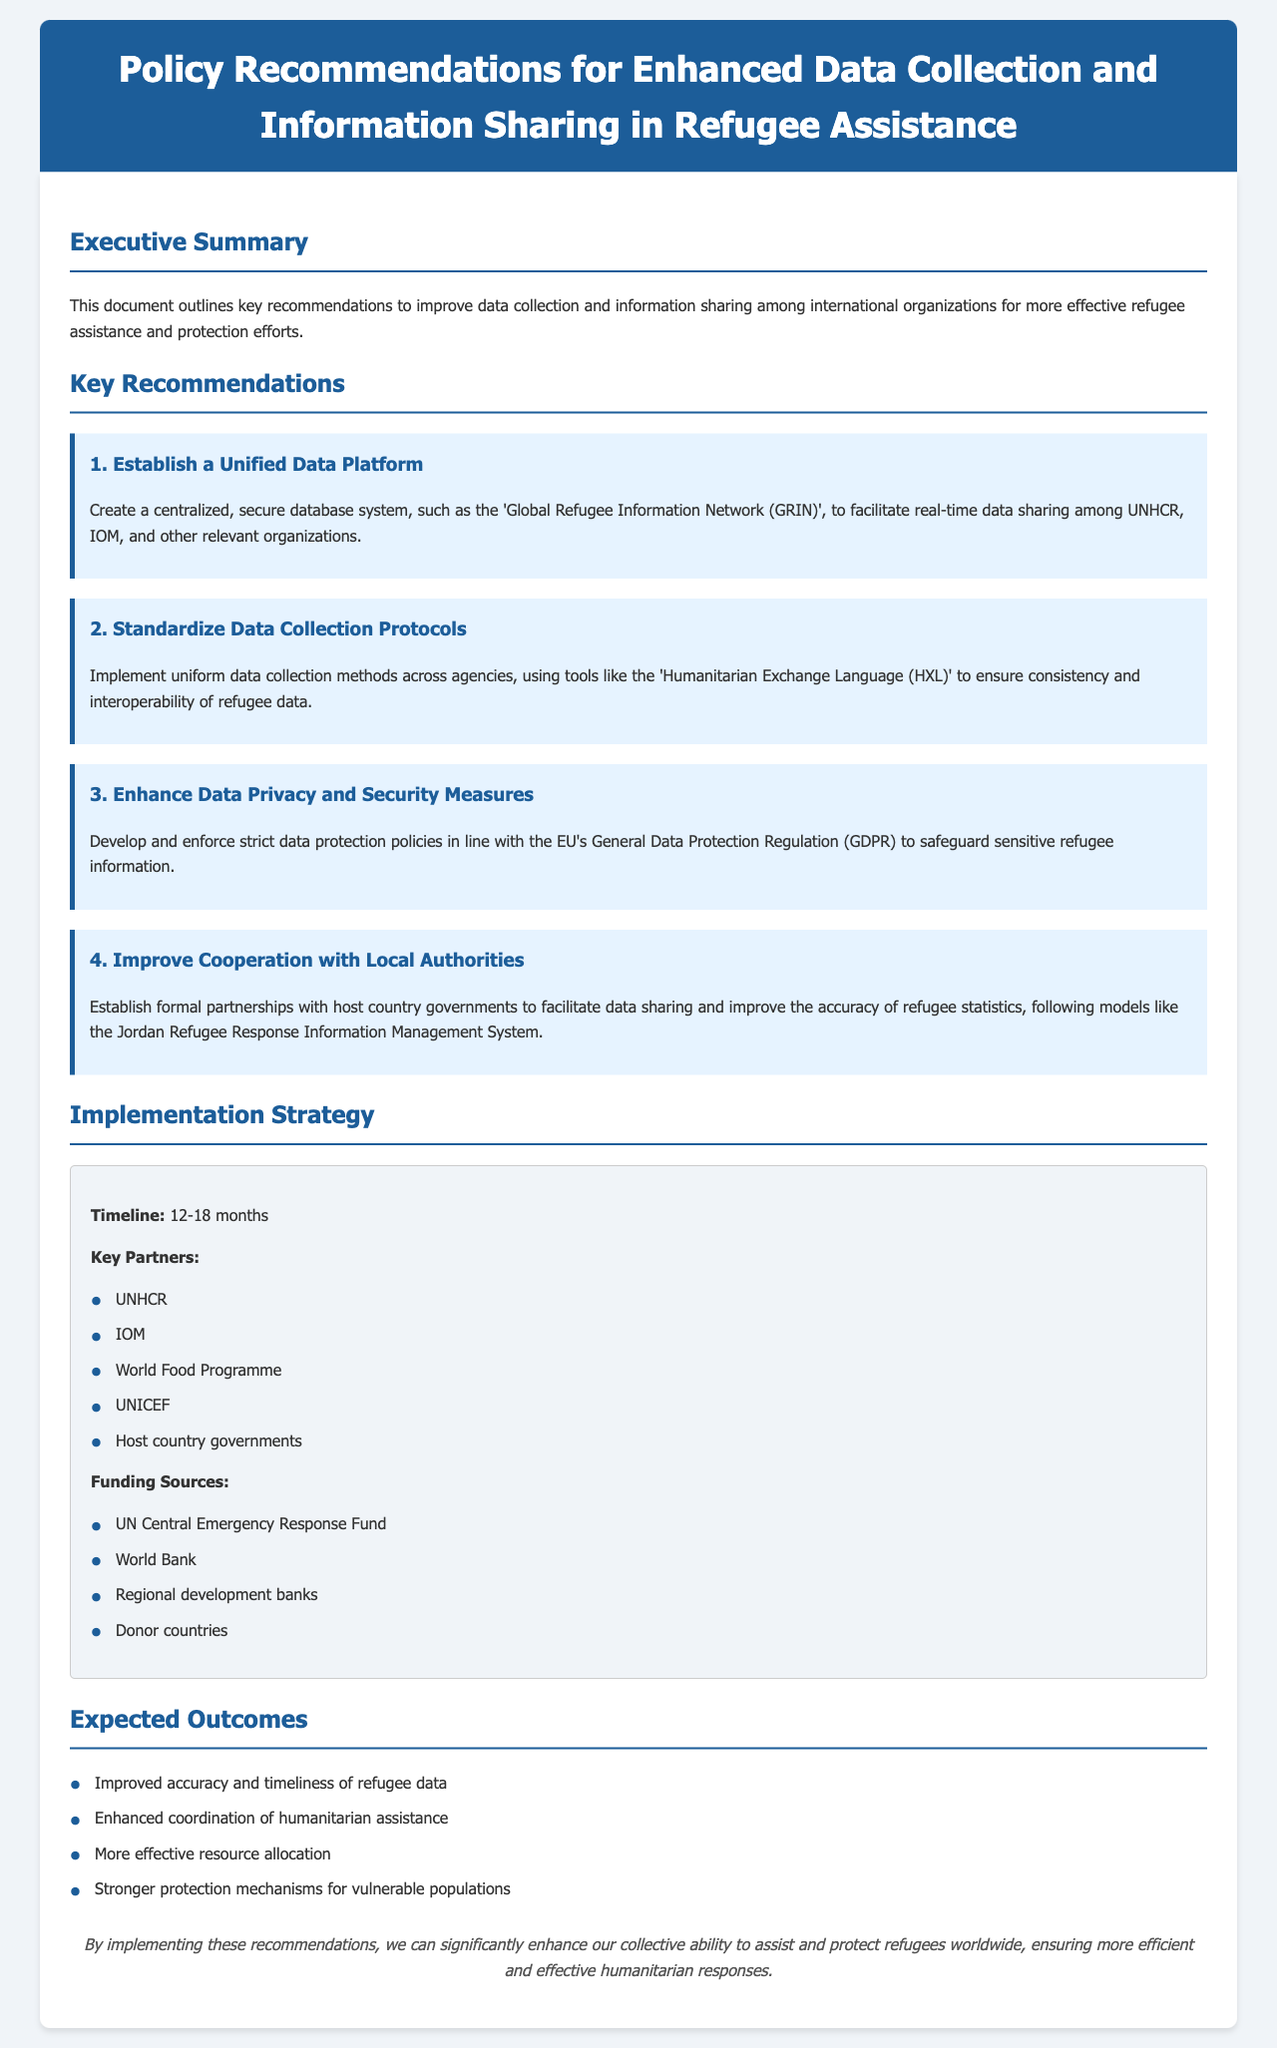What is the title of the document? The title is stated prominently at the top of the document.
Answer: Policy Recommendations for Enhanced Data Collection and Information Sharing in Refugee Assistance What is the name of the centralized database system proposed? The document introduces a specific name for the database in its recommendations section.
Answer: Global Refugee Information Network (GRIN) How many key recommendations are outlined in the document? The number of recommendations is noted in the section heading.
Answer: Four Which data protection regulation is mentioned for safeguarding refugee information? The document refers to a specific regulation related to data privacy.
Answer: GDPR What is the timeline proposed for the implementation of the recommendations? The timeline is clearly stated in the implementation strategy section.
Answer: 12-18 months Which organization is suggested as a key partner in the implementation strategy? The document lists multiple organizations in the partnership section.
Answer: UNHCR What is one expected outcome of enhancing data collection? The expected outcomes include several benefits of improved data collection mentioned in the document.
Answer: Improved accuracy and timeliness of refugee data What tool is recommended for standardizing data collection? The document specifies a tool intended to ensure consistency in data collection methods.
Answer: Humanitarian Exchange Language (HXL) Which funding source is listed for the proposed implementations? The document suggests various funding sources needed for the initiatives.
Answer: UN Central Emergency Response Fund 